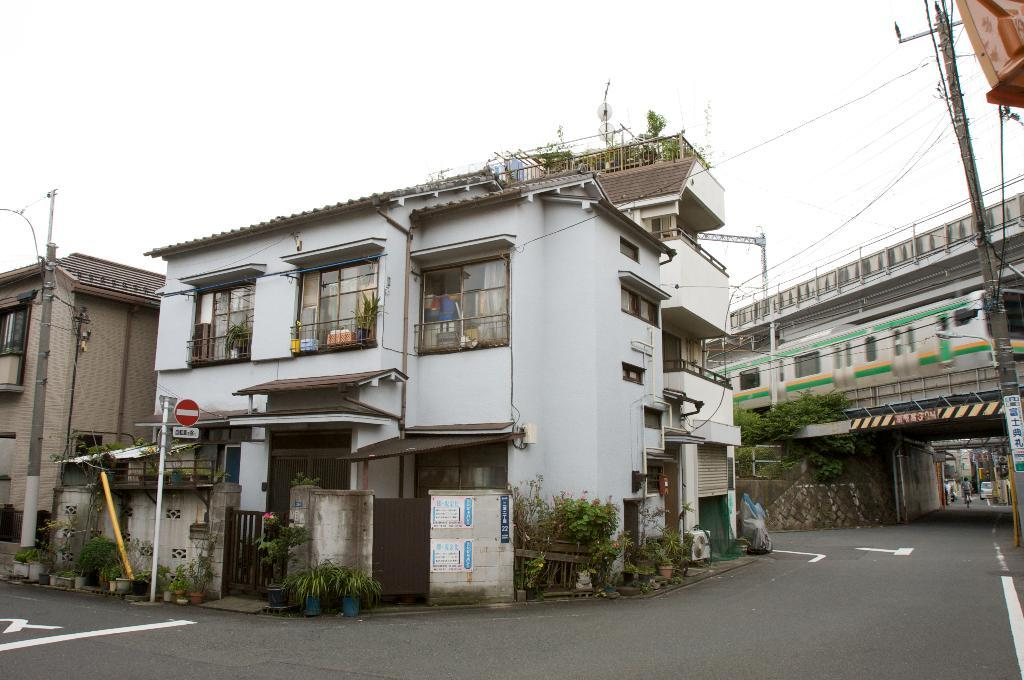What is the main feature of the image? There is a road in the image. What can be seen behind the road? There are buildings behind the road. What is located in front of the buildings? There are plants in front of the buildings. What is visible above the image? The sky is visible above the image. How many children are playing in the image? There are no children present in the image. What type of self-care activity are the sisters engaged in within the image? There are no sisters or self-care activities depicted in the image. 